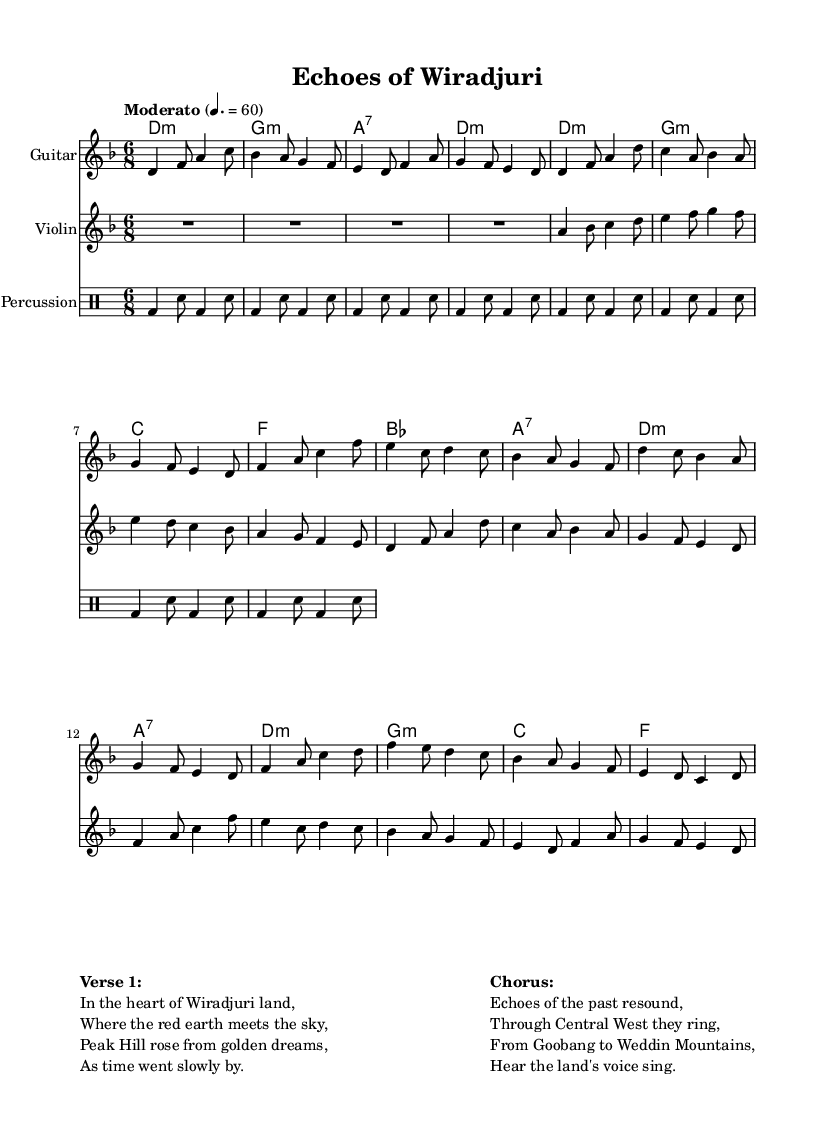What is the key signature of this music? The key signature is indicated by the sharps or flats placed at the beginning of the staffs. Here, the presence of a B flat indicates that the key signature is D minor.
Answer: D minor What is the time signature of this piece? The time signature is represented at the beginning of the sheet music; it shows the number of beats in each measure. Here, the time signature is 6/8, meaning there are six eighth notes per measure.
Answer: 6/8 What is the tempo marking for this piece? The tempo marking is indicated at the start of the music and describes the speed at which the piece should be played. The marking "Moderato" with the tempo of 60 beats per minute suggests a moderate pace.
Answer: Moderato, 60 How many measures are in the guitar part? To find the number of measures, we count the sets of notes grouped within bar lines in the guitar part. There are a total of 16 measures in the guitar music provided.
Answer: 16 What instrument is indicated for the first part? Each part of the music has instrument names specified. The first part clearly states "Guitar" at the beginning of the guitar music section.
Answer: Guitar What are the first four notes played by the violin? The first four notes are listed in sequence right after the instrument name and are connected by the written notes with correct pitch. The notes are A, B flat, C, and D.
Answer: A, B flat, C, D Which historical narrative does the music reflect? The lyrics provided in the markup capture a specific historical narrative connected to the Wiradjuri land, mentioning the region of Peak Hill and its dreams over time.
Answer: The echoes of Wiradjuri land 